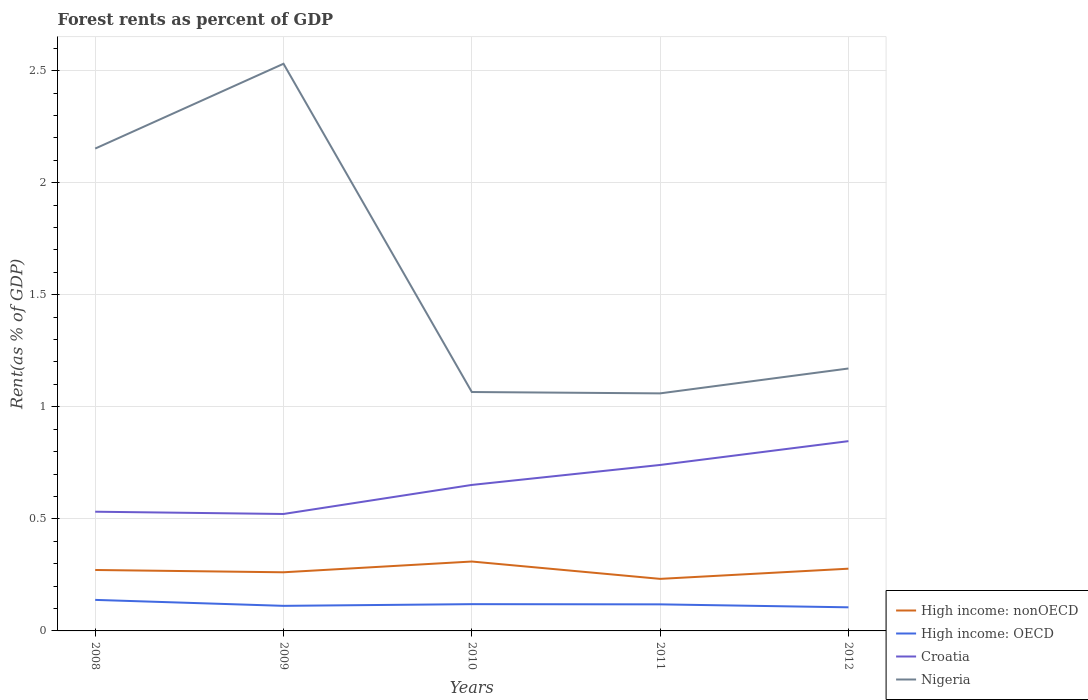How many different coloured lines are there?
Your response must be concise. 4. Across all years, what is the maximum forest rent in Croatia?
Provide a succinct answer. 0.52. What is the total forest rent in Nigeria in the graph?
Your answer should be compact. -0.38. What is the difference between the highest and the second highest forest rent in Nigeria?
Keep it short and to the point. 1.47. How many lines are there?
Offer a terse response. 4. What is the difference between two consecutive major ticks on the Y-axis?
Your answer should be very brief. 0.5. Are the values on the major ticks of Y-axis written in scientific E-notation?
Your answer should be compact. No. How many legend labels are there?
Make the answer very short. 4. What is the title of the graph?
Give a very brief answer. Forest rents as percent of GDP. Does "Armenia" appear as one of the legend labels in the graph?
Keep it short and to the point. No. What is the label or title of the Y-axis?
Give a very brief answer. Rent(as % of GDP). What is the Rent(as % of GDP) of High income: nonOECD in 2008?
Ensure brevity in your answer.  0.27. What is the Rent(as % of GDP) in High income: OECD in 2008?
Ensure brevity in your answer.  0.14. What is the Rent(as % of GDP) of Croatia in 2008?
Offer a terse response. 0.53. What is the Rent(as % of GDP) in Nigeria in 2008?
Offer a very short reply. 2.15. What is the Rent(as % of GDP) of High income: nonOECD in 2009?
Ensure brevity in your answer.  0.26. What is the Rent(as % of GDP) in High income: OECD in 2009?
Offer a very short reply. 0.11. What is the Rent(as % of GDP) of Croatia in 2009?
Offer a very short reply. 0.52. What is the Rent(as % of GDP) in Nigeria in 2009?
Offer a very short reply. 2.53. What is the Rent(as % of GDP) in High income: nonOECD in 2010?
Give a very brief answer. 0.31. What is the Rent(as % of GDP) in High income: OECD in 2010?
Offer a very short reply. 0.12. What is the Rent(as % of GDP) of Croatia in 2010?
Your response must be concise. 0.65. What is the Rent(as % of GDP) of Nigeria in 2010?
Give a very brief answer. 1.07. What is the Rent(as % of GDP) of High income: nonOECD in 2011?
Your response must be concise. 0.23. What is the Rent(as % of GDP) in High income: OECD in 2011?
Provide a succinct answer. 0.12. What is the Rent(as % of GDP) in Croatia in 2011?
Your response must be concise. 0.74. What is the Rent(as % of GDP) of Nigeria in 2011?
Make the answer very short. 1.06. What is the Rent(as % of GDP) of High income: nonOECD in 2012?
Your response must be concise. 0.28. What is the Rent(as % of GDP) in High income: OECD in 2012?
Provide a short and direct response. 0.11. What is the Rent(as % of GDP) in Croatia in 2012?
Your response must be concise. 0.85. What is the Rent(as % of GDP) in Nigeria in 2012?
Offer a terse response. 1.17. Across all years, what is the maximum Rent(as % of GDP) of High income: nonOECD?
Your answer should be very brief. 0.31. Across all years, what is the maximum Rent(as % of GDP) in High income: OECD?
Keep it short and to the point. 0.14. Across all years, what is the maximum Rent(as % of GDP) of Croatia?
Your response must be concise. 0.85. Across all years, what is the maximum Rent(as % of GDP) in Nigeria?
Give a very brief answer. 2.53. Across all years, what is the minimum Rent(as % of GDP) of High income: nonOECD?
Provide a short and direct response. 0.23. Across all years, what is the minimum Rent(as % of GDP) of High income: OECD?
Your answer should be compact. 0.11. Across all years, what is the minimum Rent(as % of GDP) of Croatia?
Your answer should be very brief. 0.52. Across all years, what is the minimum Rent(as % of GDP) of Nigeria?
Give a very brief answer. 1.06. What is the total Rent(as % of GDP) of High income: nonOECD in the graph?
Offer a very short reply. 1.35. What is the total Rent(as % of GDP) of High income: OECD in the graph?
Keep it short and to the point. 0.59. What is the total Rent(as % of GDP) of Croatia in the graph?
Your answer should be compact. 3.29. What is the total Rent(as % of GDP) of Nigeria in the graph?
Offer a terse response. 7.98. What is the difference between the Rent(as % of GDP) of High income: nonOECD in 2008 and that in 2009?
Offer a terse response. 0.01. What is the difference between the Rent(as % of GDP) of High income: OECD in 2008 and that in 2009?
Provide a succinct answer. 0.03. What is the difference between the Rent(as % of GDP) of Croatia in 2008 and that in 2009?
Your answer should be very brief. 0.01. What is the difference between the Rent(as % of GDP) in Nigeria in 2008 and that in 2009?
Provide a succinct answer. -0.38. What is the difference between the Rent(as % of GDP) of High income: nonOECD in 2008 and that in 2010?
Provide a succinct answer. -0.04. What is the difference between the Rent(as % of GDP) in High income: OECD in 2008 and that in 2010?
Your answer should be very brief. 0.02. What is the difference between the Rent(as % of GDP) of Croatia in 2008 and that in 2010?
Give a very brief answer. -0.12. What is the difference between the Rent(as % of GDP) in Nigeria in 2008 and that in 2010?
Your response must be concise. 1.09. What is the difference between the Rent(as % of GDP) of High income: nonOECD in 2008 and that in 2011?
Your response must be concise. 0.04. What is the difference between the Rent(as % of GDP) in Croatia in 2008 and that in 2011?
Your response must be concise. -0.21. What is the difference between the Rent(as % of GDP) of Nigeria in 2008 and that in 2011?
Provide a succinct answer. 1.09. What is the difference between the Rent(as % of GDP) of High income: nonOECD in 2008 and that in 2012?
Your response must be concise. -0.01. What is the difference between the Rent(as % of GDP) in High income: OECD in 2008 and that in 2012?
Provide a succinct answer. 0.03. What is the difference between the Rent(as % of GDP) in Croatia in 2008 and that in 2012?
Keep it short and to the point. -0.31. What is the difference between the Rent(as % of GDP) in Nigeria in 2008 and that in 2012?
Offer a very short reply. 0.98. What is the difference between the Rent(as % of GDP) in High income: nonOECD in 2009 and that in 2010?
Your response must be concise. -0.05. What is the difference between the Rent(as % of GDP) in High income: OECD in 2009 and that in 2010?
Your answer should be very brief. -0.01. What is the difference between the Rent(as % of GDP) in Croatia in 2009 and that in 2010?
Give a very brief answer. -0.13. What is the difference between the Rent(as % of GDP) of Nigeria in 2009 and that in 2010?
Keep it short and to the point. 1.46. What is the difference between the Rent(as % of GDP) in High income: nonOECD in 2009 and that in 2011?
Make the answer very short. 0.03. What is the difference between the Rent(as % of GDP) in High income: OECD in 2009 and that in 2011?
Keep it short and to the point. -0.01. What is the difference between the Rent(as % of GDP) of Croatia in 2009 and that in 2011?
Ensure brevity in your answer.  -0.22. What is the difference between the Rent(as % of GDP) of Nigeria in 2009 and that in 2011?
Keep it short and to the point. 1.47. What is the difference between the Rent(as % of GDP) of High income: nonOECD in 2009 and that in 2012?
Offer a very short reply. -0.02. What is the difference between the Rent(as % of GDP) in High income: OECD in 2009 and that in 2012?
Ensure brevity in your answer.  0.01. What is the difference between the Rent(as % of GDP) in Croatia in 2009 and that in 2012?
Offer a very short reply. -0.32. What is the difference between the Rent(as % of GDP) in Nigeria in 2009 and that in 2012?
Your answer should be very brief. 1.36. What is the difference between the Rent(as % of GDP) in High income: nonOECD in 2010 and that in 2011?
Provide a short and direct response. 0.08. What is the difference between the Rent(as % of GDP) in High income: OECD in 2010 and that in 2011?
Keep it short and to the point. 0. What is the difference between the Rent(as % of GDP) of Croatia in 2010 and that in 2011?
Make the answer very short. -0.09. What is the difference between the Rent(as % of GDP) in Nigeria in 2010 and that in 2011?
Your answer should be very brief. 0.01. What is the difference between the Rent(as % of GDP) of High income: nonOECD in 2010 and that in 2012?
Offer a very short reply. 0.03. What is the difference between the Rent(as % of GDP) in High income: OECD in 2010 and that in 2012?
Keep it short and to the point. 0.01. What is the difference between the Rent(as % of GDP) of Croatia in 2010 and that in 2012?
Keep it short and to the point. -0.2. What is the difference between the Rent(as % of GDP) in Nigeria in 2010 and that in 2012?
Provide a succinct answer. -0.1. What is the difference between the Rent(as % of GDP) in High income: nonOECD in 2011 and that in 2012?
Give a very brief answer. -0.05. What is the difference between the Rent(as % of GDP) of High income: OECD in 2011 and that in 2012?
Your answer should be very brief. 0.01. What is the difference between the Rent(as % of GDP) of Croatia in 2011 and that in 2012?
Your answer should be compact. -0.11. What is the difference between the Rent(as % of GDP) of Nigeria in 2011 and that in 2012?
Offer a terse response. -0.11. What is the difference between the Rent(as % of GDP) in High income: nonOECD in 2008 and the Rent(as % of GDP) in High income: OECD in 2009?
Offer a terse response. 0.16. What is the difference between the Rent(as % of GDP) of High income: nonOECD in 2008 and the Rent(as % of GDP) of Croatia in 2009?
Make the answer very short. -0.25. What is the difference between the Rent(as % of GDP) of High income: nonOECD in 2008 and the Rent(as % of GDP) of Nigeria in 2009?
Offer a terse response. -2.26. What is the difference between the Rent(as % of GDP) of High income: OECD in 2008 and the Rent(as % of GDP) of Croatia in 2009?
Your answer should be very brief. -0.38. What is the difference between the Rent(as % of GDP) in High income: OECD in 2008 and the Rent(as % of GDP) in Nigeria in 2009?
Ensure brevity in your answer.  -2.39. What is the difference between the Rent(as % of GDP) in Croatia in 2008 and the Rent(as % of GDP) in Nigeria in 2009?
Make the answer very short. -2. What is the difference between the Rent(as % of GDP) in High income: nonOECD in 2008 and the Rent(as % of GDP) in High income: OECD in 2010?
Give a very brief answer. 0.15. What is the difference between the Rent(as % of GDP) in High income: nonOECD in 2008 and the Rent(as % of GDP) in Croatia in 2010?
Your answer should be very brief. -0.38. What is the difference between the Rent(as % of GDP) of High income: nonOECD in 2008 and the Rent(as % of GDP) of Nigeria in 2010?
Provide a succinct answer. -0.79. What is the difference between the Rent(as % of GDP) in High income: OECD in 2008 and the Rent(as % of GDP) in Croatia in 2010?
Your answer should be compact. -0.51. What is the difference between the Rent(as % of GDP) in High income: OECD in 2008 and the Rent(as % of GDP) in Nigeria in 2010?
Provide a short and direct response. -0.93. What is the difference between the Rent(as % of GDP) in Croatia in 2008 and the Rent(as % of GDP) in Nigeria in 2010?
Offer a terse response. -0.53. What is the difference between the Rent(as % of GDP) in High income: nonOECD in 2008 and the Rent(as % of GDP) in High income: OECD in 2011?
Ensure brevity in your answer.  0.15. What is the difference between the Rent(as % of GDP) in High income: nonOECD in 2008 and the Rent(as % of GDP) in Croatia in 2011?
Provide a succinct answer. -0.47. What is the difference between the Rent(as % of GDP) of High income: nonOECD in 2008 and the Rent(as % of GDP) of Nigeria in 2011?
Provide a short and direct response. -0.79. What is the difference between the Rent(as % of GDP) of High income: OECD in 2008 and the Rent(as % of GDP) of Croatia in 2011?
Give a very brief answer. -0.6. What is the difference between the Rent(as % of GDP) of High income: OECD in 2008 and the Rent(as % of GDP) of Nigeria in 2011?
Provide a short and direct response. -0.92. What is the difference between the Rent(as % of GDP) in Croatia in 2008 and the Rent(as % of GDP) in Nigeria in 2011?
Ensure brevity in your answer.  -0.53. What is the difference between the Rent(as % of GDP) of High income: nonOECD in 2008 and the Rent(as % of GDP) of High income: OECD in 2012?
Your answer should be compact. 0.17. What is the difference between the Rent(as % of GDP) of High income: nonOECD in 2008 and the Rent(as % of GDP) of Croatia in 2012?
Your response must be concise. -0.57. What is the difference between the Rent(as % of GDP) of High income: nonOECD in 2008 and the Rent(as % of GDP) of Nigeria in 2012?
Keep it short and to the point. -0.9. What is the difference between the Rent(as % of GDP) of High income: OECD in 2008 and the Rent(as % of GDP) of Croatia in 2012?
Your answer should be very brief. -0.71. What is the difference between the Rent(as % of GDP) of High income: OECD in 2008 and the Rent(as % of GDP) of Nigeria in 2012?
Keep it short and to the point. -1.03. What is the difference between the Rent(as % of GDP) in Croatia in 2008 and the Rent(as % of GDP) in Nigeria in 2012?
Provide a short and direct response. -0.64. What is the difference between the Rent(as % of GDP) of High income: nonOECD in 2009 and the Rent(as % of GDP) of High income: OECD in 2010?
Make the answer very short. 0.14. What is the difference between the Rent(as % of GDP) in High income: nonOECD in 2009 and the Rent(as % of GDP) in Croatia in 2010?
Your answer should be compact. -0.39. What is the difference between the Rent(as % of GDP) of High income: nonOECD in 2009 and the Rent(as % of GDP) of Nigeria in 2010?
Ensure brevity in your answer.  -0.8. What is the difference between the Rent(as % of GDP) in High income: OECD in 2009 and the Rent(as % of GDP) in Croatia in 2010?
Give a very brief answer. -0.54. What is the difference between the Rent(as % of GDP) of High income: OECD in 2009 and the Rent(as % of GDP) of Nigeria in 2010?
Your answer should be very brief. -0.95. What is the difference between the Rent(as % of GDP) of Croatia in 2009 and the Rent(as % of GDP) of Nigeria in 2010?
Offer a terse response. -0.54. What is the difference between the Rent(as % of GDP) of High income: nonOECD in 2009 and the Rent(as % of GDP) of High income: OECD in 2011?
Your answer should be compact. 0.14. What is the difference between the Rent(as % of GDP) of High income: nonOECD in 2009 and the Rent(as % of GDP) of Croatia in 2011?
Give a very brief answer. -0.48. What is the difference between the Rent(as % of GDP) of High income: nonOECD in 2009 and the Rent(as % of GDP) of Nigeria in 2011?
Make the answer very short. -0.8. What is the difference between the Rent(as % of GDP) of High income: OECD in 2009 and the Rent(as % of GDP) of Croatia in 2011?
Provide a short and direct response. -0.63. What is the difference between the Rent(as % of GDP) in High income: OECD in 2009 and the Rent(as % of GDP) in Nigeria in 2011?
Keep it short and to the point. -0.95. What is the difference between the Rent(as % of GDP) of Croatia in 2009 and the Rent(as % of GDP) of Nigeria in 2011?
Provide a succinct answer. -0.54. What is the difference between the Rent(as % of GDP) in High income: nonOECD in 2009 and the Rent(as % of GDP) in High income: OECD in 2012?
Offer a very short reply. 0.16. What is the difference between the Rent(as % of GDP) of High income: nonOECD in 2009 and the Rent(as % of GDP) of Croatia in 2012?
Your answer should be compact. -0.59. What is the difference between the Rent(as % of GDP) of High income: nonOECD in 2009 and the Rent(as % of GDP) of Nigeria in 2012?
Provide a short and direct response. -0.91. What is the difference between the Rent(as % of GDP) in High income: OECD in 2009 and the Rent(as % of GDP) in Croatia in 2012?
Provide a succinct answer. -0.73. What is the difference between the Rent(as % of GDP) in High income: OECD in 2009 and the Rent(as % of GDP) in Nigeria in 2012?
Your answer should be compact. -1.06. What is the difference between the Rent(as % of GDP) of Croatia in 2009 and the Rent(as % of GDP) of Nigeria in 2012?
Your answer should be compact. -0.65. What is the difference between the Rent(as % of GDP) of High income: nonOECD in 2010 and the Rent(as % of GDP) of High income: OECD in 2011?
Offer a terse response. 0.19. What is the difference between the Rent(as % of GDP) of High income: nonOECD in 2010 and the Rent(as % of GDP) of Croatia in 2011?
Offer a very short reply. -0.43. What is the difference between the Rent(as % of GDP) in High income: nonOECD in 2010 and the Rent(as % of GDP) in Nigeria in 2011?
Give a very brief answer. -0.75. What is the difference between the Rent(as % of GDP) in High income: OECD in 2010 and the Rent(as % of GDP) in Croatia in 2011?
Keep it short and to the point. -0.62. What is the difference between the Rent(as % of GDP) in High income: OECD in 2010 and the Rent(as % of GDP) in Nigeria in 2011?
Provide a succinct answer. -0.94. What is the difference between the Rent(as % of GDP) of Croatia in 2010 and the Rent(as % of GDP) of Nigeria in 2011?
Ensure brevity in your answer.  -0.41. What is the difference between the Rent(as % of GDP) in High income: nonOECD in 2010 and the Rent(as % of GDP) in High income: OECD in 2012?
Provide a short and direct response. 0.2. What is the difference between the Rent(as % of GDP) in High income: nonOECD in 2010 and the Rent(as % of GDP) in Croatia in 2012?
Provide a succinct answer. -0.54. What is the difference between the Rent(as % of GDP) in High income: nonOECD in 2010 and the Rent(as % of GDP) in Nigeria in 2012?
Keep it short and to the point. -0.86. What is the difference between the Rent(as % of GDP) in High income: OECD in 2010 and the Rent(as % of GDP) in Croatia in 2012?
Offer a terse response. -0.73. What is the difference between the Rent(as % of GDP) of High income: OECD in 2010 and the Rent(as % of GDP) of Nigeria in 2012?
Give a very brief answer. -1.05. What is the difference between the Rent(as % of GDP) in Croatia in 2010 and the Rent(as % of GDP) in Nigeria in 2012?
Make the answer very short. -0.52. What is the difference between the Rent(as % of GDP) in High income: nonOECD in 2011 and the Rent(as % of GDP) in High income: OECD in 2012?
Make the answer very short. 0.13. What is the difference between the Rent(as % of GDP) of High income: nonOECD in 2011 and the Rent(as % of GDP) of Croatia in 2012?
Offer a terse response. -0.61. What is the difference between the Rent(as % of GDP) in High income: nonOECD in 2011 and the Rent(as % of GDP) in Nigeria in 2012?
Make the answer very short. -0.94. What is the difference between the Rent(as % of GDP) of High income: OECD in 2011 and the Rent(as % of GDP) of Croatia in 2012?
Provide a short and direct response. -0.73. What is the difference between the Rent(as % of GDP) in High income: OECD in 2011 and the Rent(as % of GDP) in Nigeria in 2012?
Offer a terse response. -1.05. What is the difference between the Rent(as % of GDP) in Croatia in 2011 and the Rent(as % of GDP) in Nigeria in 2012?
Your response must be concise. -0.43. What is the average Rent(as % of GDP) of High income: nonOECD per year?
Your answer should be very brief. 0.27. What is the average Rent(as % of GDP) of High income: OECD per year?
Offer a very short reply. 0.12. What is the average Rent(as % of GDP) in Croatia per year?
Provide a succinct answer. 0.66. What is the average Rent(as % of GDP) in Nigeria per year?
Offer a terse response. 1.6. In the year 2008, what is the difference between the Rent(as % of GDP) of High income: nonOECD and Rent(as % of GDP) of High income: OECD?
Your answer should be compact. 0.13. In the year 2008, what is the difference between the Rent(as % of GDP) of High income: nonOECD and Rent(as % of GDP) of Croatia?
Ensure brevity in your answer.  -0.26. In the year 2008, what is the difference between the Rent(as % of GDP) of High income: nonOECD and Rent(as % of GDP) of Nigeria?
Provide a succinct answer. -1.88. In the year 2008, what is the difference between the Rent(as % of GDP) of High income: OECD and Rent(as % of GDP) of Croatia?
Offer a very short reply. -0.39. In the year 2008, what is the difference between the Rent(as % of GDP) of High income: OECD and Rent(as % of GDP) of Nigeria?
Offer a very short reply. -2.01. In the year 2008, what is the difference between the Rent(as % of GDP) of Croatia and Rent(as % of GDP) of Nigeria?
Offer a terse response. -1.62. In the year 2009, what is the difference between the Rent(as % of GDP) in High income: nonOECD and Rent(as % of GDP) in High income: OECD?
Keep it short and to the point. 0.15. In the year 2009, what is the difference between the Rent(as % of GDP) in High income: nonOECD and Rent(as % of GDP) in Croatia?
Offer a terse response. -0.26. In the year 2009, what is the difference between the Rent(as % of GDP) in High income: nonOECD and Rent(as % of GDP) in Nigeria?
Give a very brief answer. -2.27. In the year 2009, what is the difference between the Rent(as % of GDP) of High income: OECD and Rent(as % of GDP) of Croatia?
Your answer should be compact. -0.41. In the year 2009, what is the difference between the Rent(as % of GDP) in High income: OECD and Rent(as % of GDP) in Nigeria?
Ensure brevity in your answer.  -2.42. In the year 2009, what is the difference between the Rent(as % of GDP) of Croatia and Rent(as % of GDP) of Nigeria?
Give a very brief answer. -2.01. In the year 2010, what is the difference between the Rent(as % of GDP) of High income: nonOECD and Rent(as % of GDP) of High income: OECD?
Your answer should be compact. 0.19. In the year 2010, what is the difference between the Rent(as % of GDP) in High income: nonOECD and Rent(as % of GDP) in Croatia?
Your answer should be compact. -0.34. In the year 2010, what is the difference between the Rent(as % of GDP) in High income: nonOECD and Rent(as % of GDP) in Nigeria?
Offer a very short reply. -0.76. In the year 2010, what is the difference between the Rent(as % of GDP) of High income: OECD and Rent(as % of GDP) of Croatia?
Offer a terse response. -0.53. In the year 2010, what is the difference between the Rent(as % of GDP) of High income: OECD and Rent(as % of GDP) of Nigeria?
Offer a terse response. -0.95. In the year 2010, what is the difference between the Rent(as % of GDP) in Croatia and Rent(as % of GDP) in Nigeria?
Give a very brief answer. -0.41. In the year 2011, what is the difference between the Rent(as % of GDP) in High income: nonOECD and Rent(as % of GDP) in High income: OECD?
Your response must be concise. 0.11. In the year 2011, what is the difference between the Rent(as % of GDP) of High income: nonOECD and Rent(as % of GDP) of Croatia?
Keep it short and to the point. -0.51. In the year 2011, what is the difference between the Rent(as % of GDP) of High income: nonOECD and Rent(as % of GDP) of Nigeria?
Keep it short and to the point. -0.83. In the year 2011, what is the difference between the Rent(as % of GDP) in High income: OECD and Rent(as % of GDP) in Croatia?
Your answer should be very brief. -0.62. In the year 2011, what is the difference between the Rent(as % of GDP) of High income: OECD and Rent(as % of GDP) of Nigeria?
Your response must be concise. -0.94. In the year 2011, what is the difference between the Rent(as % of GDP) in Croatia and Rent(as % of GDP) in Nigeria?
Offer a terse response. -0.32. In the year 2012, what is the difference between the Rent(as % of GDP) in High income: nonOECD and Rent(as % of GDP) in High income: OECD?
Keep it short and to the point. 0.17. In the year 2012, what is the difference between the Rent(as % of GDP) of High income: nonOECD and Rent(as % of GDP) of Croatia?
Offer a terse response. -0.57. In the year 2012, what is the difference between the Rent(as % of GDP) of High income: nonOECD and Rent(as % of GDP) of Nigeria?
Your response must be concise. -0.89. In the year 2012, what is the difference between the Rent(as % of GDP) of High income: OECD and Rent(as % of GDP) of Croatia?
Provide a succinct answer. -0.74. In the year 2012, what is the difference between the Rent(as % of GDP) of High income: OECD and Rent(as % of GDP) of Nigeria?
Your response must be concise. -1.07. In the year 2012, what is the difference between the Rent(as % of GDP) of Croatia and Rent(as % of GDP) of Nigeria?
Provide a short and direct response. -0.32. What is the ratio of the Rent(as % of GDP) in High income: nonOECD in 2008 to that in 2009?
Give a very brief answer. 1.04. What is the ratio of the Rent(as % of GDP) in High income: OECD in 2008 to that in 2009?
Offer a terse response. 1.24. What is the ratio of the Rent(as % of GDP) in Croatia in 2008 to that in 2009?
Your answer should be very brief. 1.02. What is the ratio of the Rent(as % of GDP) in Nigeria in 2008 to that in 2009?
Offer a very short reply. 0.85. What is the ratio of the Rent(as % of GDP) in High income: nonOECD in 2008 to that in 2010?
Give a very brief answer. 0.88. What is the ratio of the Rent(as % of GDP) of High income: OECD in 2008 to that in 2010?
Your response must be concise. 1.16. What is the ratio of the Rent(as % of GDP) in Croatia in 2008 to that in 2010?
Your response must be concise. 0.82. What is the ratio of the Rent(as % of GDP) of Nigeria in 2008 to that in 2010?
Offer a terse response. 2.02. What is the ratio of the Rent(as % of GDP) of High income: nonOECD in 2008 to that in 2011?
Your answer should be compact. 1.17. What is the ratio of the Rent(as % of GDP) of High income: OECD in 2008 to that in 2011?
Make the answer very short. 1.17. What is the ratio of the Rent(as % of GDP) of Croatia in 2008 to that in 2011?
Provide a short and direct response. 0.72. What is the ratio of the Rent(as % of GDP) in Nigeria in 2008 to that in 2011?
Ensure brevity in your answer.  2.03. What is the ratio of the Rent(as % of GDP) in High income: nonOECD in 2008 to that in 2012?
Make the answer very short. 0.98. What is the ratio of the Rent(as % of GDP) in High income: OECD in 2008 to that in 2012?
Ensure brevity in your answer.  1.31. What is the ratio of the Rent(as % of GDP) in Croatia in 2008 to that in 2012?
Give a very brief answer. 0.63. What is the ratio of the Rent(as % of GDP) of Nigeria in 2008 to that in 2012?
Keep it short and to the point. 1.84. What is the ratio of the Rent(as % of GDP) of High income: nonOECD in 2009 to that in 2010?
Your answer should be compact. 0.84. What is the ratio of the Rent(as % of GDP) of High income: OECD in 2009 to that in 2010?
Offer a very short reply. 0.94. What is the ratio of the Rent(as % of GDP) in Croatia in 2009 to that in 2010?
Offer a terse response. 0.8. What is the ratio of the Rent(as % of GDP) in Nigeria in 2009 to that in 2010?
Offer a terse response. 2.37. What is the ratio of the Rent(as % of GDP) of High income: nonOECD in 2009 to that in 2011?
Your answer should be compact. 1.13. What is the ratio of the Rent(as % of GDP) of High income: OECD in 2009 to that in 2011?
Your answer should be very brief. 0.94. What is the ratio of the Rent(as % of GDP) in Croatia in 2009 to that in 2011?
Make the answer very short. 0.7. What is the ratio of the Rent(as % of GDP) of Nigeria in 2009 to that in 2011?
Your answer should be compact. 2.39. What is the ratio of the Rent(as % of GDP) of High income: nonOECD in 2009 to that in 2012?
Provide a succinct answer. 0.94. What is the ratio of the Rent(as % of GDP) in High income: OECD in 2009 to that in 2012?
Provide a short and direct response. 1.06. What is the ratio of the Rent(as % of GDP) of Croatia in 2009 to that in 2012?
Offer a very short reply. 0.62. What is the ratio of the Rent(as % of GDP) in Nigeria in 2009 to that in 2012?
Your answer should be very brief. 2.16. What is the ratio of the Rent(as % of GDP) in High income: nonOECD in 2010 to that in 2011?
Ensure brevity in your answer.  1.33. What is the ratio of the Rent(as % of GDP) of High income: OECD in 2010 to that in 2011?
Offer a very short reply. 1.01. What is the ratio of the Rent(as % of GDP) of Croatia in 2010 to that in 2011?
Your answer should be very brief. 0.88. What is the ratio of the Rent(as % of GDP) in Nigeria in 2010 to that in 2011?
Provide a short and direct response. 1.01. What is the ratio of the Rent(as % of GDP) in High income: nonOECD in 2010 to that in 2012?
Make the answer very short. 1.12. What is the ratio of the Rent(as % of GDP) in High income: OECD in 2010 to that in 2012?
Offer a very short reply. 1.13. What is the ratio of the Rent(as % of GDP) in Croatia in 2010 to that in 2012?
Your answer should be very brief. 0.77. What is the ratio of the Rent(as % of GDP) of Nigeria in 2010 to that in 2012?
Offer a terse response. 0.91. What is the ratio of the Rent(as % of GDP) of High income: nonOECD in 2011 to that in 2012?
Give a very brief answer. 0.84. What is the ratio of the Rent(as % of GDP) of High income: OECD in 2011 to that in 2012?
Keep it short and to the point. 1.13. What is the ratio of the Rent(as % of GDP) of Croatia in 2011 to that in 2012?
Keep it short and to the point. 0.87. What is the ratio of the Rent(as % of GDP) of Nigeria in 2011 to that in 2012?
Offer a very short reply. 0.91. What is the difference between the highest and the second highest Rent(as % of GDP) in High income: nonOECD?
Ensure brevity in your answer.  0.03. What is the difference between the highest and the second highest Rent(as % of GDP) in High income: OECD?
Your answer should be compact. 0.02. What is the difference between the highest and the second highest Rent(as % of GDP) in Croatia?
Your answer should be compact. 0.11. What is the difference between the highest and the second highest Rent(as % of GDP) in Nigeria?
Make the answer very short. 0.38. What is the difference between the highest and the lowest Rent(as % of GDP) of High income: nonOECD?
Your answer should be compact. 0.08. What is the difference between the highest and the lowest Rent(as % of GDP) in High income: OECD?
Provide a short and direct response. 0.03. What is the difference between the highest and the lowest Rent(as % of GDP) in Croatia?
Your response must be concise. 0.32. What is the difference between the highest and the lowest Rent(as % of GDP) of Nigeria?
Your answer should be compact. 1.47. 